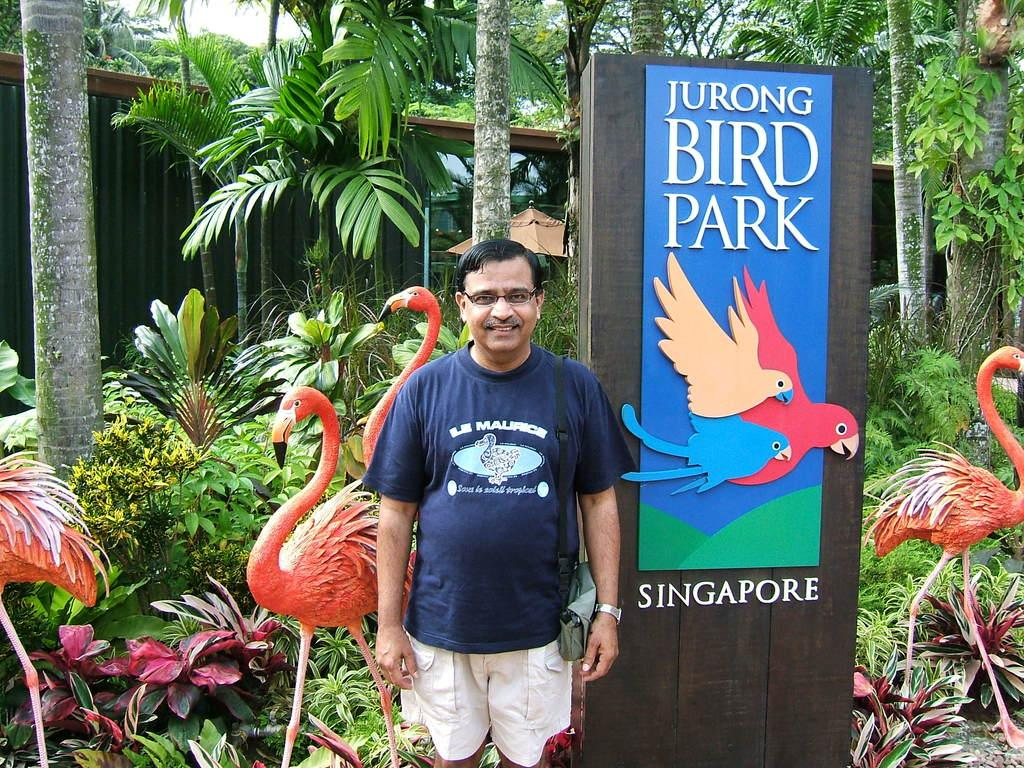What type of living organisms can be seen in the image? Plants and trees are visible in the image. What additional object can be seen in the image? There is a banner in the image. Who is present in the image? There is a man standing in the image. What decorative items are featured in the image? There are crane statues in the image. What type of whistle can be heard in the image? There is no whistle present in the image, and therefore no sound can be heard. How much sugar is being used in the image? There is no reference to sugar or any food items in the image. 